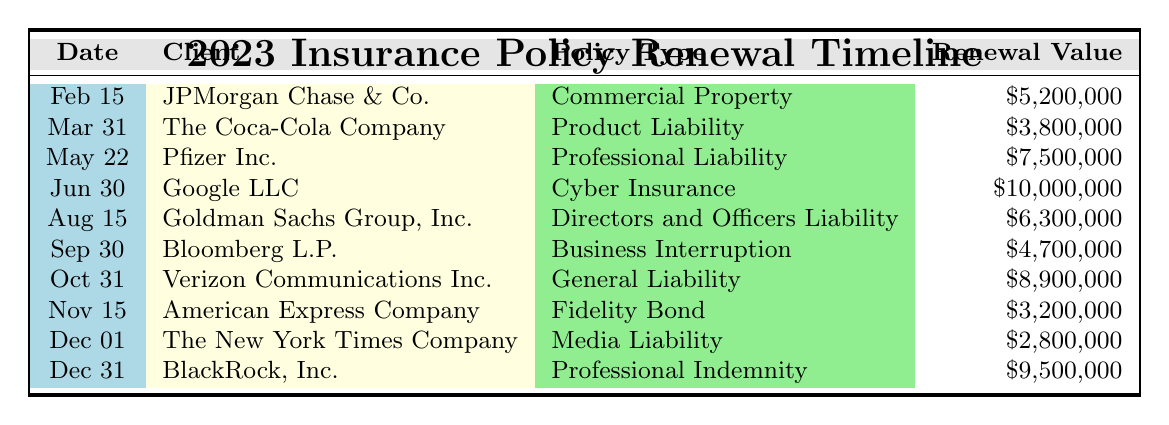What is the renewal value for Google LLC's Cyber Insurance policy? The table lists Google LLC under the date June 30 with the policy type Cyber Insurance, and the renewal value for this policy is $10,000,000.
Answer: $10,000,000 Which client has the highest renewal value in this table? Looking through the renewal values, the highest value is $10,000,000 for Google LLC's Cyber Insurance policy.
Answer: Google LLC How many renewal dates are within the second half of 2023? The second half of 2023 includes the dates from July 1 to December 31. The renewal dates are on June 30, August 15, September 30, October 31, November 15, December 1, and December 31, totaling seven dates.
Answer: 7 What is the total renewal value for all clients listed in the table? Summing the renewal values: $5,200,000 + $3,800,000 + $7,500,000 + $10,000,000 + $6,300,000 + $4,700,000 + $8,900,000 + $3,200,000 + $2,800,000 + $9,500,000 equals $60,900,000.
Answer: $60,900,000 Is there any policy type that has a renewal value of less than $3,000,000? Reviewing the renewal values, the lowest is $2,800,000 for The New York Times Company's Media Liability policy, which is less than $3,000,000, confirming that there is a policy type under that amount.
Answer: Yes Which client(s) have renewal dates in the month of August? The table lists one renewal date in August, on August 15 for Goldman Sachs Group, Inc., which is the only client with a renewal during that month.
Answer: Goldman Sachs Group, Inc What is the average renewal value for policies that fall under the Directors and Officers Liability type? There is one policy type (Directors and Officers Liability) in the table with a renewal value of $6,300,000, thus making the average value equal to the renewal value itself, which is $6,300,000.
Answer: $6,300,000 How many clients have renewal values greater than $5,000,000? The clients with renewal values greater than $5,000,000 are JPMorgan Chase & Co. ($5,200,000), Pfizer Inc. ($7,500,000), Google LLC ($10,000,000), Goldman Sachs Group, Inc. ($6,300,000), Verizon Communications Inc. ($8,900,000), and BlackRock, Inc. ($9,500,000). This sums up to six clients.
Answer: 6 